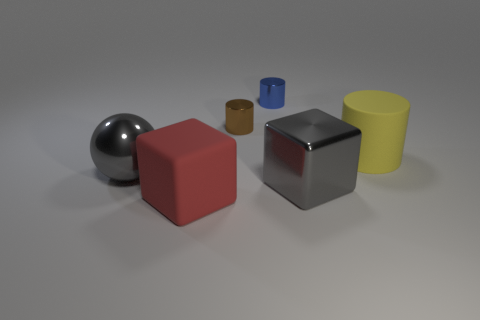Add 2 small gray cylinders. How many objects exist? 8 Subtract all balls. How many objects are left? 5 Subtract all metal cylinders. Subtract all blue metallic objects. How many objects are left? 3 Add 1 big yellow matte cylinders. How many big yellow matte cylinders are left? 2 Add 3 metallic cylinders. How many metallic cylinders exist? 5 Subtract 0 purple cylinders. How many objects are left? 6 